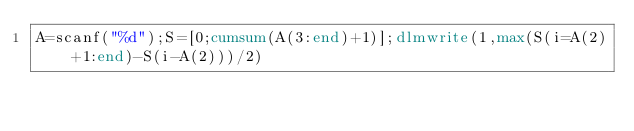<code> <loc_0><loc_0><loc_500><loc_500><_Octave_>A=scanf("%d");S=[0;cumsum(A(3:end)+1)];dlmwrite(1,max(S(i=A(2)+1:end)-S(i-A(2)))/2)</code> 